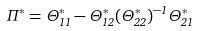<formula> <loc_0><loc_0><loc_500><loc_500>\Pi ^ { * } = \Theta ^ { * } _ { 1 1 } - \Theta ^ { * } _ { 1 2 } ( \Theta ^ { * } _ { 2 2 } ) ^ { - 1 } \Theta ^ { * } _ { 2 1 }</formula> 